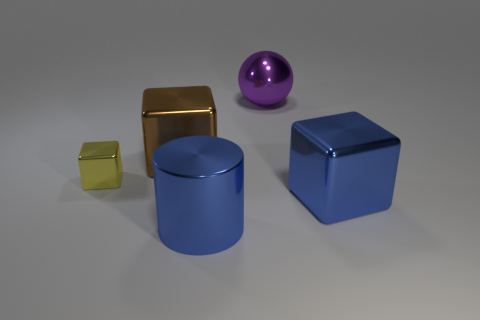Is there a metallic cylinder behind the shiny cube that is to the right of the blue metal cylinder?
Make the answer very short. No. Are there any yellow objects of the same shape as the big purple shiny thing?
Offer a terse response. No. There is a large metal cube on the right side of the brown cube on the left side of the sphere; what number of yellow metal cubes are to the right of it?
Your response must be concise. 0. Is the color of the cylinder the same as the metal block that is in front of the tiny thing?
Give a very brief answer. Yes. What number of objects are objects that are in front of the brown metallic block or blocks in front of the tiny yellow metallic cube?
Provide a short and direct response. 3. Is the number of purple balls that are to the left of the brown shiny cube greater than the number of big brown shiny things on the left side of the yellow metal thing?
Make the answer very short. No. There is a large block right of the blue object that is left of the big cube in front of the brown metallic object; what is its material?
Provide a succinct answer. Metal. Is the shape of the object behind the brown block the same as the blue metallic thing that is on the right side of the big shiny sphere?
Your answer should be very brief. No. Are there any cubes of the same size as the metallic cylinder?
Provide a short and direct response. Yes. What number of brown things are cylinders or tiny objects?
Your response must be concise. 0. 